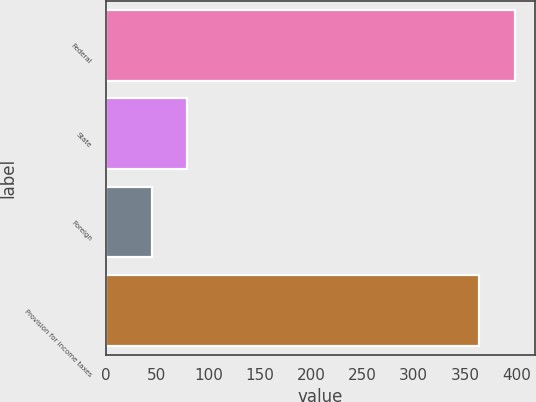Convert chart. <chart><loc_0><loc_0><loc_500><loc_500><bar_chart><fcel>Federal<fcel>State<fcel>Foreign<fcel>Provision for income taxes<nl><fcel>398.4<fcel>79.4<fcel>45<fcel>364<nl></chart> 